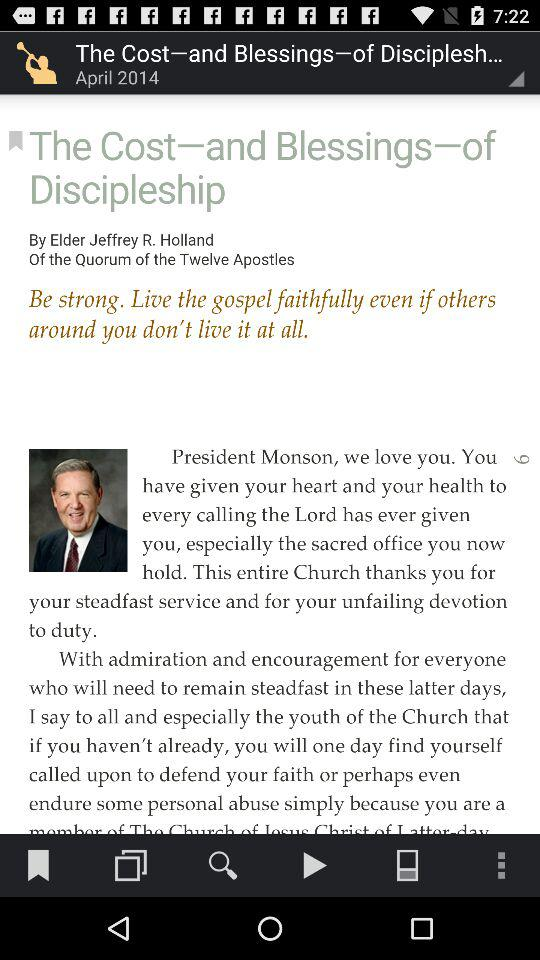What is the title of the blog? The title of the blog is "The Cost-and Blessings-of Discipleship". 